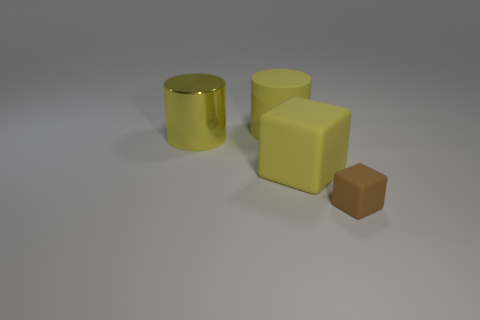Add 3 brown matte things. How many objects exist? 7 Subtract 2 cylinders. How many cylinders are left? 0 Add 2 large yellow metal cylinders. How many large yellow metal cylinders are left? 3 Add 4 yellow objects. How many yellow objects exist? 7 Subtract 0 purple cylinders. How many objects are left? 4 Subtract all brown cubes. Subtract all yellow balls. How many cubes are left? 1 Subtract all yellow cubes. How many blue cylinders are left? 0 Subtract all brown blocks. Subtract all blue shiny cubes. How many objects are left? 3 